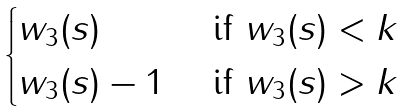<formula> <loc_0><loc_0><loc_500><loc_500>\begin{cases} w _ { 3 } ( s ) & { \text { if } } w _ { 3 } ( s ) < k \\ w _ { 3 } ( s ) - 1 & { \text { if } } w _ { 3 } ( s ) > k \end{cases}</formula> 